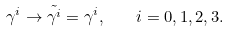<formula> <loc_0><loc_0><loc_500><loc_500>\gamma ^ { i } \rightarrow \tilde { \gamma ^ { i } } = \gamma ^ { i } , \quad i = 0 , 1 , 2 , 3 .</formula> 